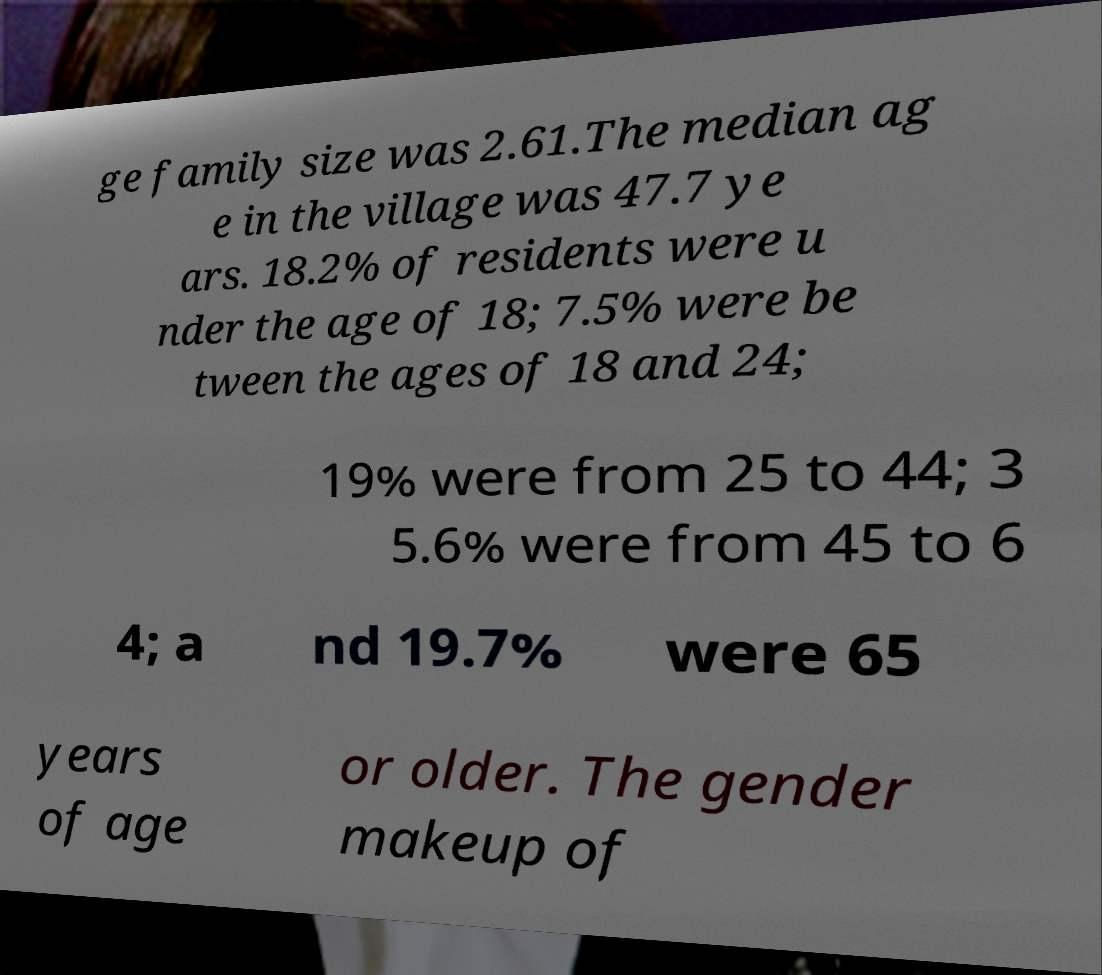For documentation purposes, I need the text within this image transcribed. Could you provide that? ge family size was 2.61.The median ag e in the village was 47.7 ye ars. 18.2% of residents were u nder the age of 18; 7.5% were be tween the ages of 18 and 24; 19% were from 25 to 44; 3 5.6% were from 45 to 6 4; a nd 19.7% were 65 years of age or older. The gender makeup of 